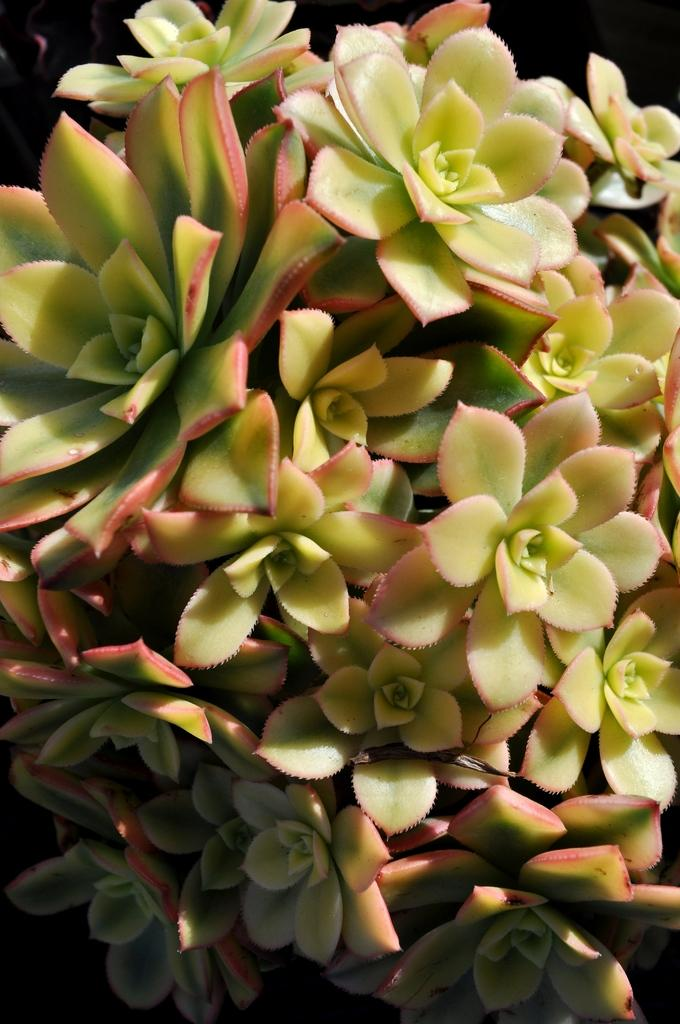What type of living organisms can be seen in the image? There are flowers in the image. What is the color of the background in the image? The background of the image is dark. What type of beetle can be seen crawling on the rice in the image? There is no beetle or rice present in the image; it only features flowers and a dark background. 